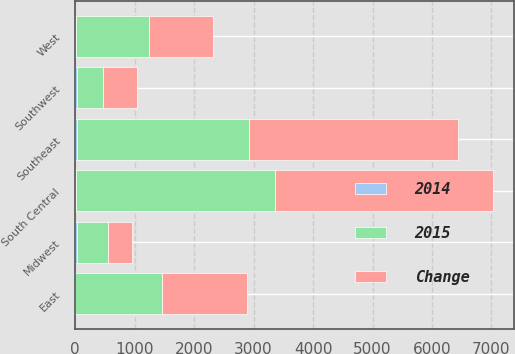Convert chart to OTSL. <chart><loc_0><loc_0><loc_500><loc_500><stacked_bar_chart><ecel><fcel>East<fcel>Midwest<fcel>Southeast<fcel>South Central<fcel>Southwest<fcel>West<nl><fcel>Change<fcel>1430<fcel>412<fcel>3511<fcel>3656<fcel>571<fcel>1082<nl><fcel>2015<fcel>1451<fcel>527<fcel>2901<fcel>3358<fcel>425<fcel>1226<nl><fcel>2014<fcel>1<fcel>22<fcel>21<fcel>9<fcel>34<fcel>12<nl></chart> 